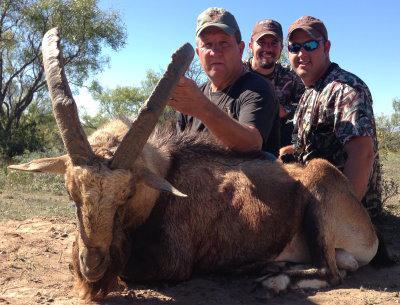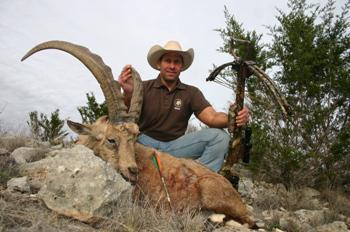The first image is the image on the left, the second image is the image on the right. Given the left and right images, does the statement "A hunter is touching an ibex's horns." hold true? Answer yes or no. Yes. The first image is the image on the left, the second image is the image on the right. For the images displayed, is the sentence "An image shows one man in a hat behind a downed animal, holding onto the tip of one horn with his hand." factually correct? Answer yes or no. Yes. 